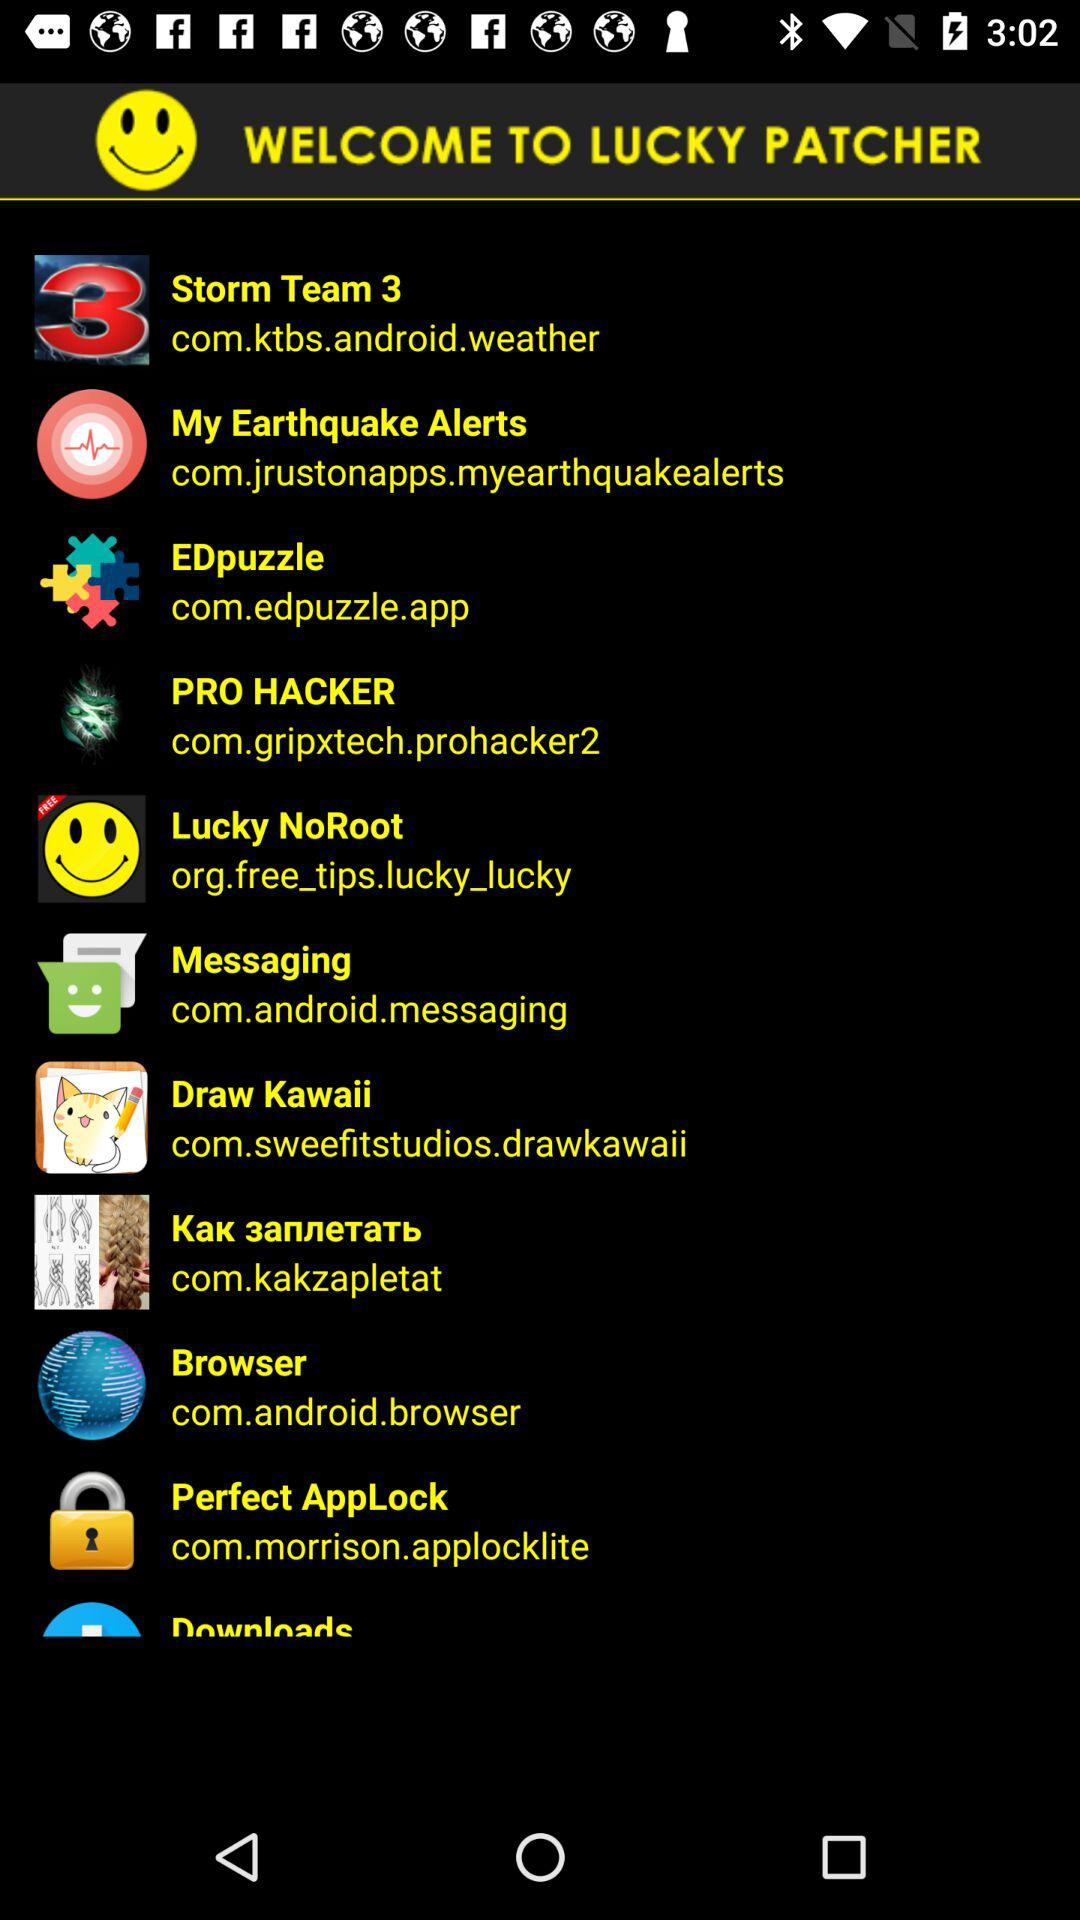What is the web site for Storm Team 3 patching?
When the provided information is insufficient, respond with <no answer>. <no answer> 